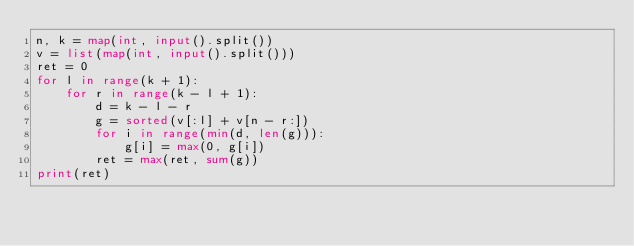Convert code to text. <code><loc_0><loc_0><loc_500><loc_500><_Python_>n, k = map(int, input().split())
v = list(map(int, input().split()))
ret = 0
for l in range(k + 1):
    for r in range(k - l + 1):
        d = k - l - r
        g = sorted(v[:l] + v[n - r:])
        for i in range(min(d, len(g))):
            g[i] = max(0, g[i])
        ret = max(ret, sum(g))
print(ret)</code> 